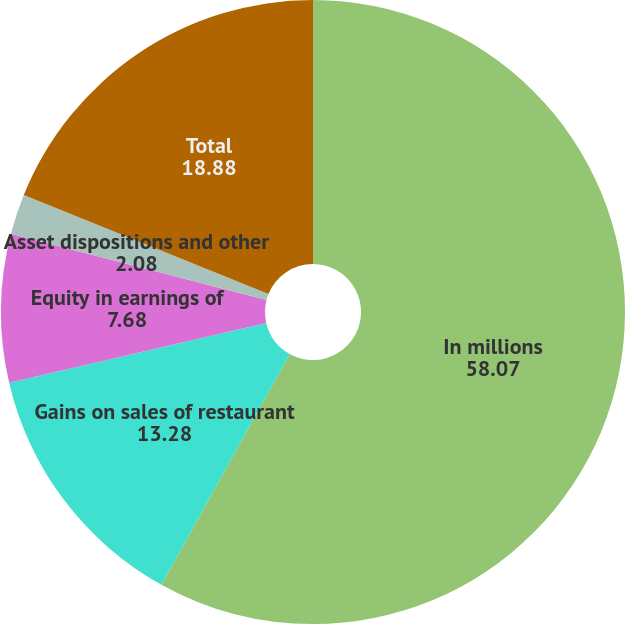Convert chart to OTSL. <chart><loc_0><loc_0><loc_500><loc_500><pie_chart><fcel>In millions<fcel>Gains on sales of restaurant<fcel>Equity in earnings of<fcel>Asset dispositions and other<fcel>Total<nl><fcel>58.07%<fcel>13.28%<fcel>7.68%<fcel>2.08%<fcel>18.88%<nl></chart> 